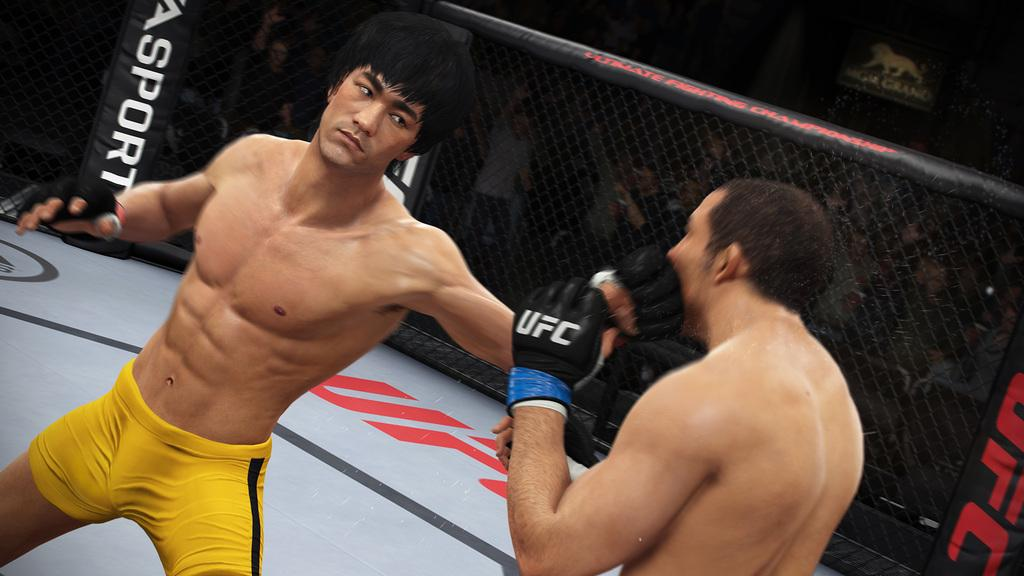<image>
Relay a brief, clear account of the picture shown. A fighter is wearing gloves with the ufc logo on them. 